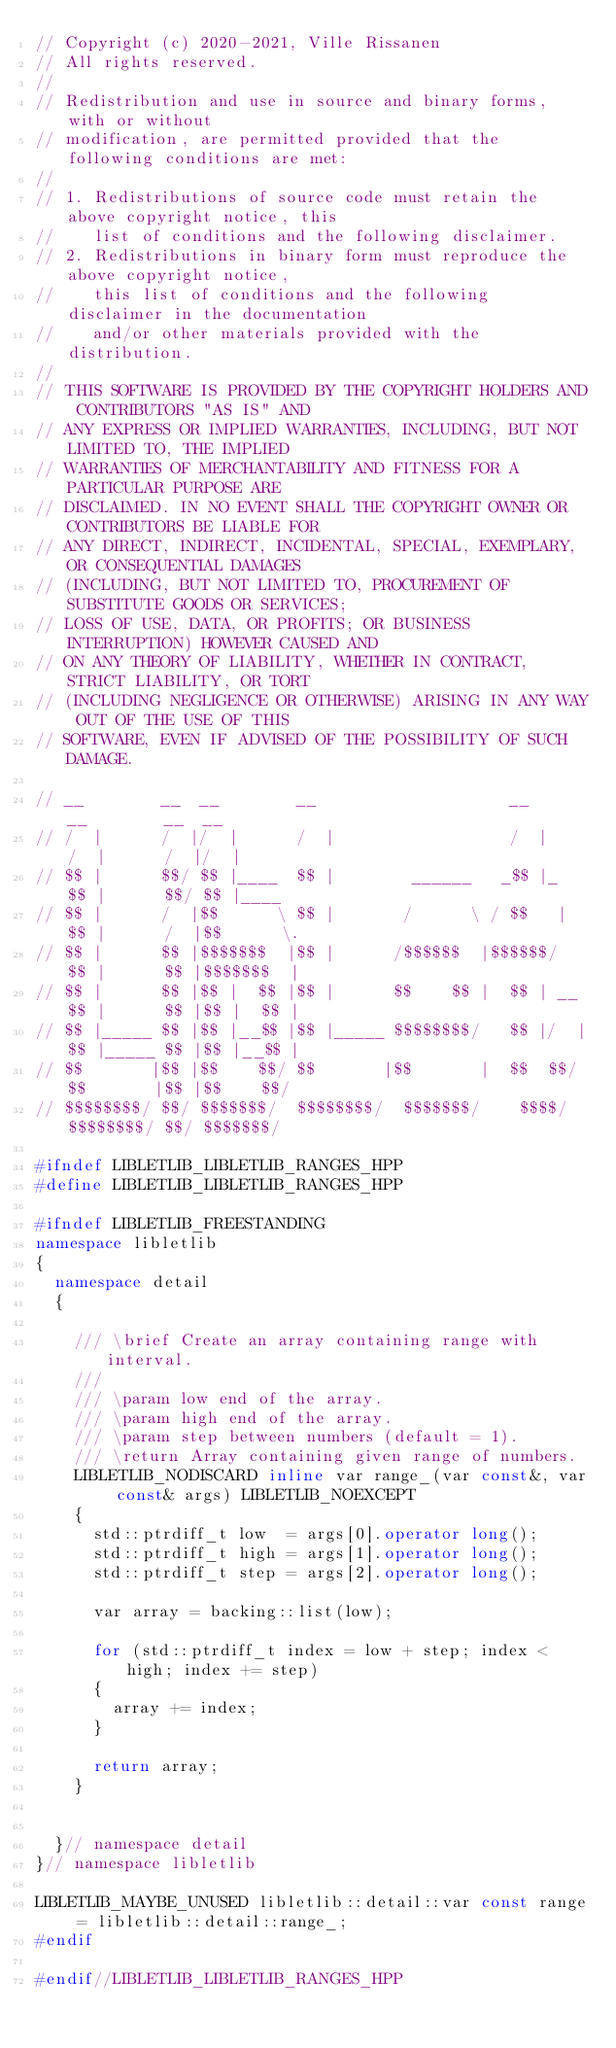<code> <loc_0><loc_0><loc_500><loc_500><_C++_>// Copyright (c) 2020-2021, Ville Rissanen
// All rights reserved.
//
// Redistribution and use in source and binary forms, with or without
// modification, are permitted provided that the following conditions are met:
//
// 1. Redistributions of source code must retain the above copyright notice, this
//    list of conditions and the following disclaimer.
// 2. Redistributions in binary form must reproduce the above copyright notice,
//    this list of conditions and the following disclaimer in the documentation
//    and/or other materials provided with the distribution.
//
// THIS SOFTWARE IS PROVIDED BY THE COPYRIGHT HOLDERS AND CONTRIBUTORS "AS IS" AND
// ANY EXPRESS OR IMPLIED WARRANTIES, INCLUDING, BUT NOT LIMITED TO, THE IMPLIED
// WARRANTIES OF MERCHANTABILITY AND FITNESS FOR A PARTICULAR PURPOSE ARE
// DISCLAIMED. IN NO EVENT SHALL THE COPYRIGHT OWNER OR CONTRIBUTORS BE LIABLE FOR
// ANY DIRECT, INDIRECT, INCIDENTAL, SPECIAL, EXEMPLARY, OR CONSEQUENTIAL DAMAGES
// (INCLUDING, BUT NOT LIMITED TO, PROCUREMENT OF SUBSTITUTE GOODS OR SERVICES;
// LOSS OF USE, DATA, OR PROFITS; OR BUSINESS INTERRUPTION) HOWEVER CAUSED AND
// ON ANY THEORY OF LIABILITY, WHETHER IN CONTRACT, STRICT LIABILITY, OR TORT
// (INCLUDING NEGLIGENCE OR OTHERWISE) ARISING IN ANY WAY OUT OF THE USE OF THIS
// SOFTWARE, EVEN IF ADVISED OF THE POSSIBILITY OF SUCH DAMAGE.

// __        __  __        __                    __      __        __  __
// /  |      /  |/  |      /  |                  /  |    /  |      /  |/  |
// $$ |      $$/ $$ |____  $$ |        ______   _$$ |_   $$ |      $$/ $$ |____
// $$ |      /  |$$      \ $$ |       /      \ / $$   |  $$ |      /  |$$      \.
// $$ |      $$ |$$$$$$$  |$$ |      /$$$$$$  |$$$$$$/   $$ |      $$ |$$$$$$$  |
// $$ |      $$ |$$ |  $$ |$$ |      $$    $$ |  $$ | __ $$ |      $$ |$$ |  $$ |
// $$ |_____ $$ |$$ |__$$ |$$ |_____ $$$$$$$$/   $$ |/  |$$ |_____ $$ |$$ |__$$ |
// $$       |$$ |$$    $$/ $$       |$$       |  $$  $$/ $$       |$$ |$$    $$/
// $$$$$$$$/ $$/ $$$$$$$/  $$$$$$$$/  $$$$$$$/    $$$$/  $$$$$$$$/ $$/ $$$$$$$/

#ifndef LIBLETLIB_LIBLETLIB_RANGES_HPP
#define LIBLETLIB_LIBLETLIB_RANGES_HPP

#ifndef LIBLETLIB_FREESTANDING
namespace libletlib
{
	namespace detail
	{

		/// \brief Create an array containing range with interval.
		///
		/// \param low end of the array.
		/// \param high end of the array.
		/// \param step between numbers (default = 1).
		/// \return Array containing given range of numbers.
		LIBLETLIB_NODISCARD inline var range_(var const&, var const& args) LIBLETLIB_NOEXCEPT
		{
			std::ptrdiff_t low  = args[0].operator long();
			std::ptrdiff_t high = args[1].operator long();
			std::ptrdiff_t step = args[2].operator long();

			var array = backing::list(low);

			for (std::ptrdiff_t index = low + step; index < high; index += step)
			{
				array += index;
			}

			return array;
		}


	}// namespace detail
}// namespace libletlib

LIBLETLIB_MAYBE_UNUSED libletlib::detail::var const range = libletlib::detail::range_;
#endif

#endif//LIBLETLIB_LIBLETLIB_RANGES_HPP
</code> 